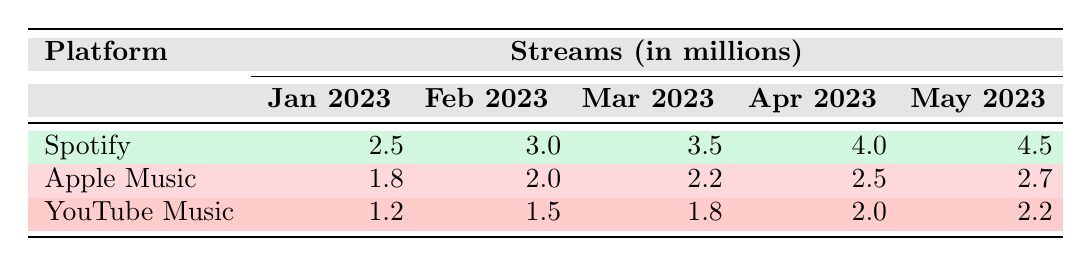What was the total number of streams for Spotify in March 2023? In March 2023, Spotify had 3.5 million streams according to the table.
Answer: 3.5 million Which platform had the highest streams in April 2023? By comparing the streams for each platform in April 2023, Spotify had 4.0 million, Apple Music had 2.5 million, and YouTube Music had 2.0 million. Therefore, Spotify had the highest streams.
Answer: Spotify What was the increase in streams for Apple Music from January to May 2023? For Apple Music, the streams were 1.8 million in January and increased to 2.7 million in May. The increase is 2.7 - 1.8 = 0.9 million.
Answer: 0.9 million Did YouTube Music ever exceed 2 million streams in the given months? The highest number of streams for YouTube Music in the table is 2.2 million in May 2023, which exceeds 2 million.
Answer: Yes What was the average number of streams for Spotify over the five months? The total streams for Spotify are 2.5 + 3.0 + 3.5 + 4.0 + 4.5 = 17.5 million. Dividing by 5 gives 17.5 / 5 = 3.5 million as the average.
Answer: 3.5 million Which platform had the least growth in streams from January to May 2023? Analyzing the growth: Spotify grew from 2.5 to 4.5 million (2.0 million increase), Apple Music grew from 1.8 to 2.7 million (0.9 million increase), and YouTube Music grew from 1.2 to 2.2 million (1.0 million increase). Apple Music had the least growth of 0.9 million.
Answer: Apple Music What was the total number of streams across all platforms in February 2023? To find the total for February 2023, add the streams for each platform: Spotify (3.0) + Apple Music (2.0) + YouTube Music (1.5) = 6.5 million.
Answer: 6.5 million Did the total streams for all platforms in March exceed that of February? The total for March is Spotify (3.5) + Apple Music (2.2) + YouTube Music (1.8) = 7.5 million. The total for February is 6.5 million. Since 7.5 > 6.5, March exceeded February's total.
Answer: Yes 